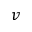<formula> <loc_0><loc_0><loc_500><loc_500>v</formula> 